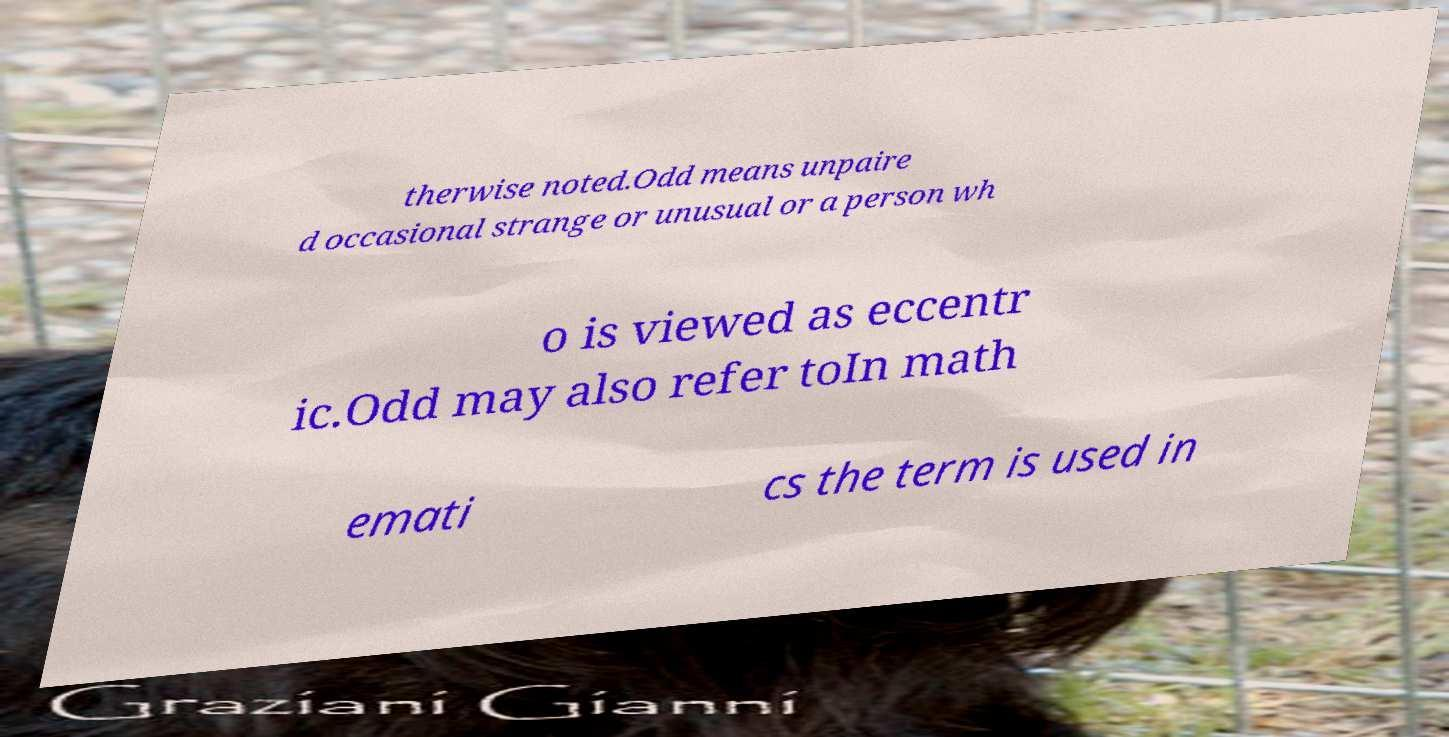Can you accurately transcribe the text from the provided image for me? therwise noted.Odd means unpaire d occasional strange or unusual or a person wh o is viewed as eccentr ic.Odd may also refer toIn math emati cs the term is used in 